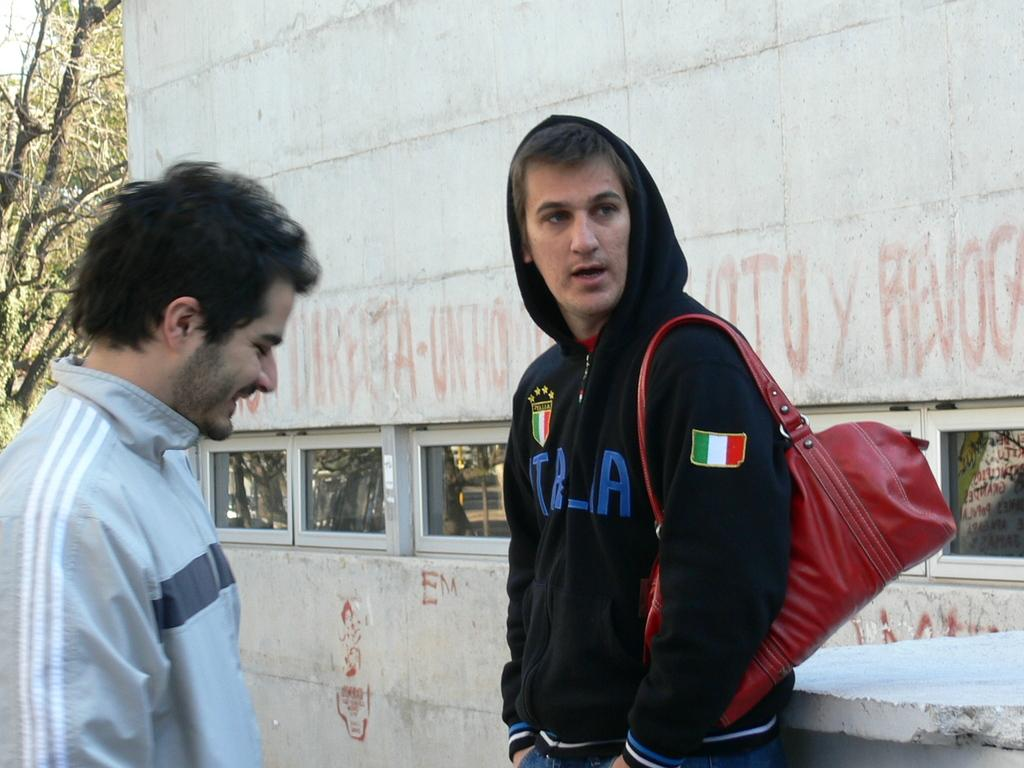<image>
Provide a brief description of the given image. A man with an Italia sweatshirt talks to his friend. 